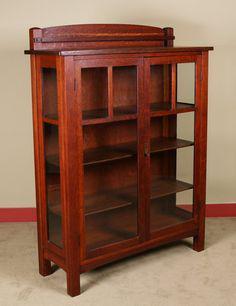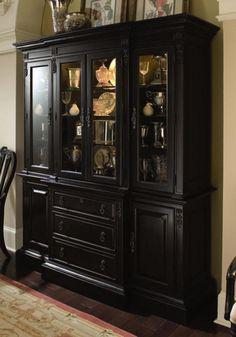The first image is the image on the left, the second image is the image on the right. Given the left and right images, does the statement "A tall, wide wooden hutch has an upper section with at least three doors that sits directly on a lower section with two panel doors and at least three drawers." hold true? Answer yes or no. Yes. 